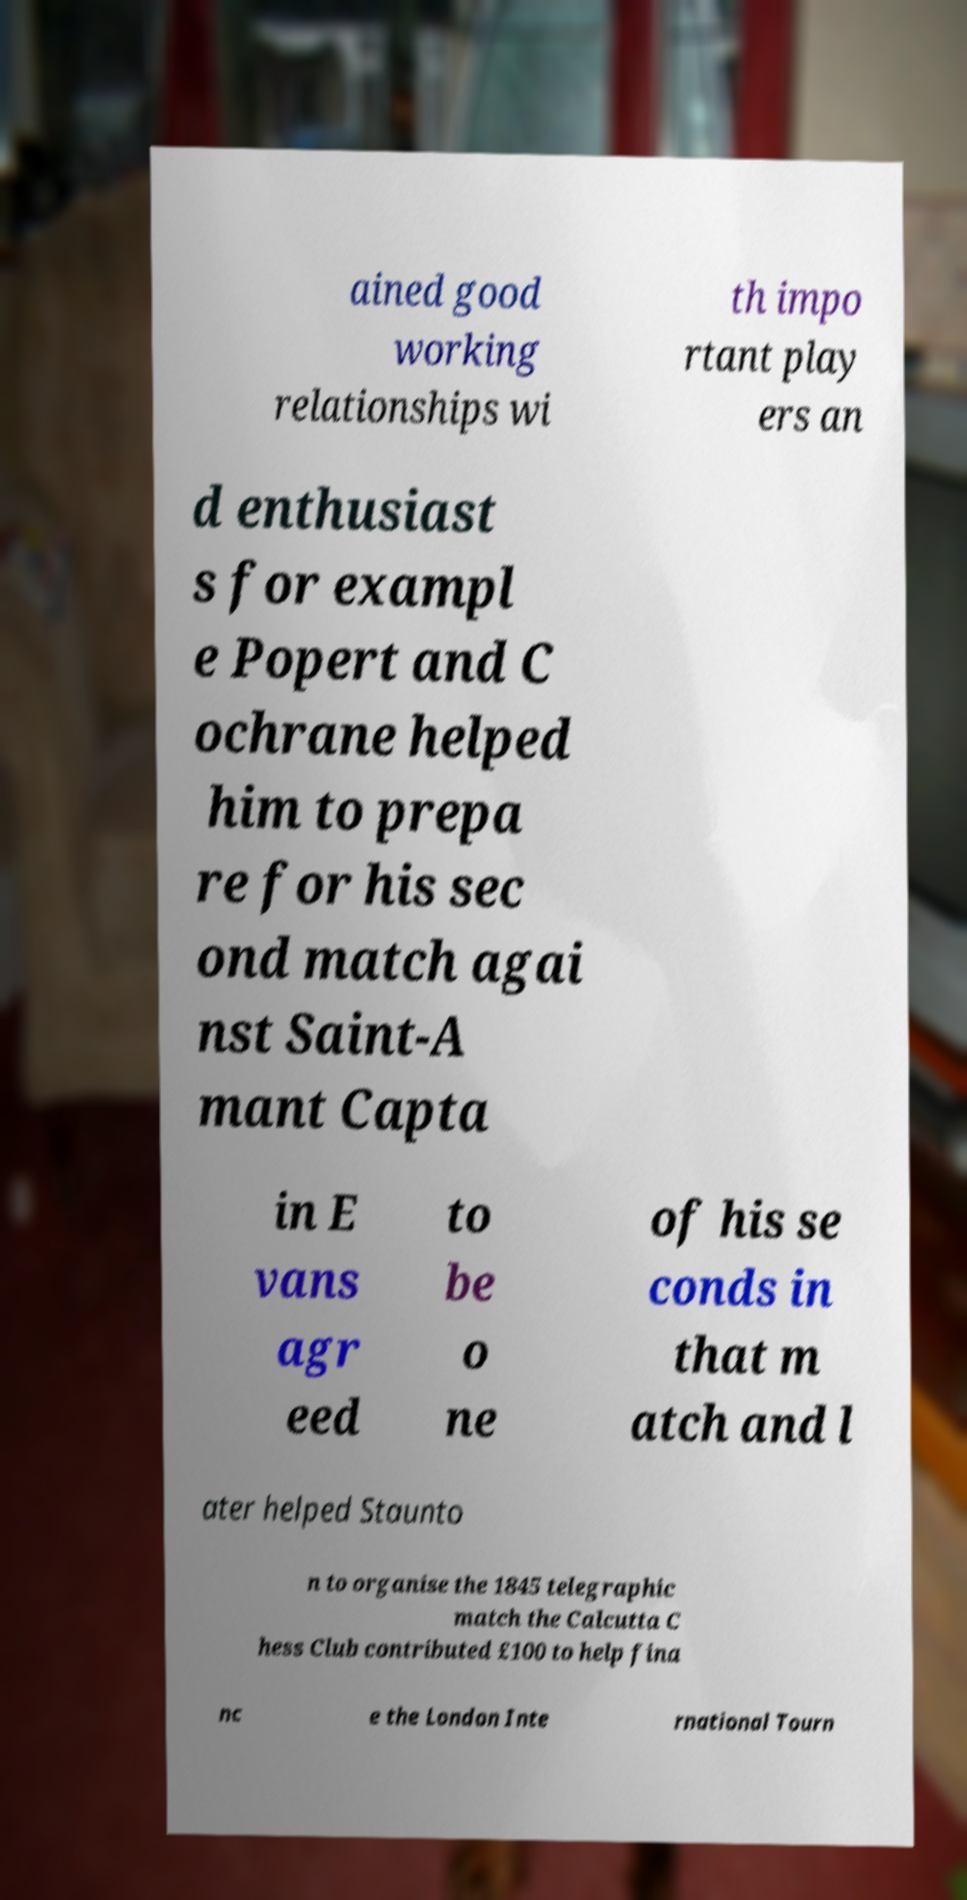Please read and relay the text visible in this image. What does it say? ained good working relationships wi th impo rtant play ers an d enthusiast s for exampl e Popert and C ochrane helped him to prepa re for his sec ond match agai nst Saint-A mant Capta in E vans agr eed to be o ne of his se conds in that m atch and l ater helped Staunto n to organise the 1845 telegraphic match the Calcutta C hess Club contributed £100 to help fina nc e the London Inte rnational Tourn 